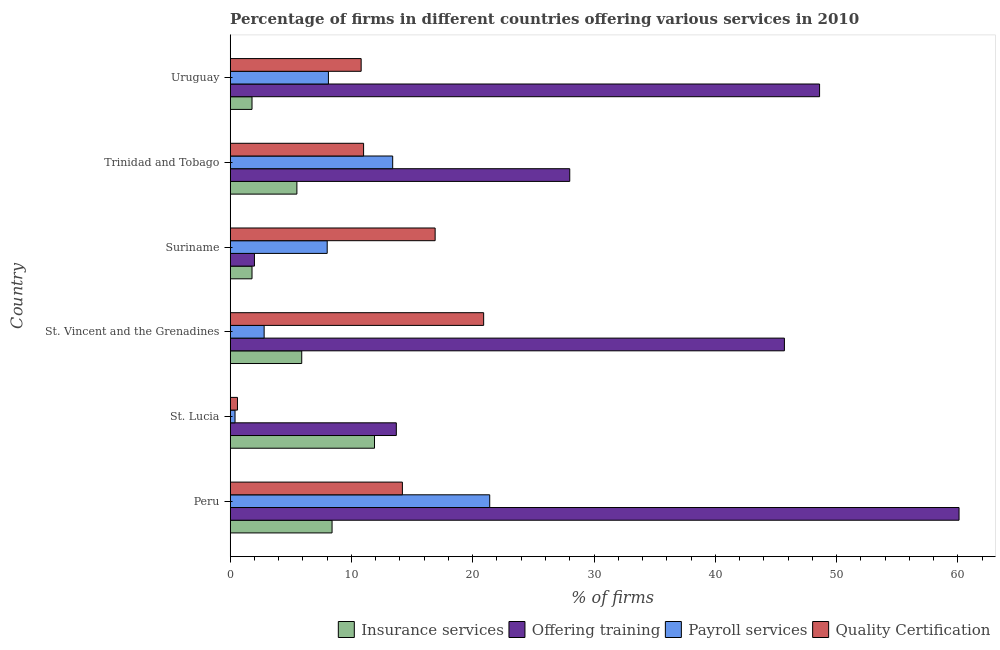How many different coloured bars are there?
Offer a very short reply. 4. Are the number of bars on each tick of the Y-axis equal?
Give a very brief answer. Yes. How many bars are there on the 3rd tick from the top?
Your response must be concise. 4. How many bars are there on the 1st tick from the bottom?
Ensure brevity in your answer.  4. What is the label of the 6th group of bars from the top?
Provide a succinct answer. Peru. Across all countries, what is the maximum percentage of firms offering payroll services?
Ensure brevity in your answer.  21.4. Across all countries, what is the minimum percentage of firms offering payroll services?
Your answer should be very brief. 0.4. In which country was the percentage of firms offering insurance services maximum?
Your answer should be compact. St. Lucia. In which country was the percentage of firms offering payroll services minimum?
Offer a very short reply. St. Lucia. What is the total percentage of firms offering quality certification in the graph?
Your answer should be compact. 74.4. What is the difference between the percentage of firms offering training in St. Lucia and that in Trinidad and Tobago?
Provide a short and direct response. -14.3. What is the average percentage of firms offering payroll services per country?
Your answer should be very brief. 9.02. What is the ratio of the percentage of firms offering training in St. Lucia to that in Uruguay?
Make the answer very short. 0.28. Is the percentage of firms offering insurance services in St. Lucia less than that in Suriname?
Your answer should be compact. No. Is the difference between the percentage of firms offering payroll services in Trinidad and Tobago and Uruguay greater than the difference between the percentage of firms offering insurance services in Trinidad and Tobago and Uruguay?
Provide a succinct answer. Yes. What is the difference between the highest and the lowest percentage of firms offering quality certification?
Ensure brevity in your answer.  20.3. In how many countries, is the percentage of firms offering payroll services greater than the average percentage of firms offering payroll services taken over all countries?
Offer a very short reply. 2. What does the 3rd bar from the top in St. Lucia represents?
Ensure brevity in your answer.  Offering training. What does the 1st bar from the bottom in St. Vincent and the Grenadines represents?
Give a very brief answer. Insurance services. Are the values on the major ticks of X-axis written in scientific E-notation?
Give a very brief answer. No. Does the graph contain any zero values?
Provide a short and direct response. No. Does the graph contain grids?
Offer a terse response. No. How are the legend labels stacked?
Give a very brief answer. Horizontal. What is the title of the graph?
Provide a short and direct response. Percentage of firms in different countries offering various services in 2010. Does "Belgium" appear as one of the legend labels in the graph?
Your answer should be compact. No. What is the label or title of the X-axis?
Your answer should be very brief. % of firms. What is the % of firms of Offering training in Peru?
Provide a short and direct response. 60.1. What is the % of firms in Payroll services in Peru?
Your answer should be compact. 21.4. What is the % of firms of Quality Certification in Peru?
Make the answer very short. 14.2. What is the % of firms of Insurance services in St. Lucia?
Offer a terse response. 11.9. What is the % of firms of Offering training in St. Lucia?
Your answer should be compact. 13.7. What is the % of firms in Quality Certification in St. Lucia?
Ensure brevity in your answer.  0.6. What is the % of firms of Insurance services in St. Vincent and the Grenadines?
Your response must be concise. 5.9. What is the % of firms in Offering training in St. Vincent and the Grenadines?
Make the answer very short. 45.7. What is the % of firms of Payroll services in St. Vincent and the Grenadines?
Provide a succinct answer. 2.8. What is the % of firms in Quality Certification in St. Vincent and the Grenadines?
Provide a short and direct response. 20.9. What is the % of firms in Insurance services in Suriname?
Ensure brevity in your answer.  1.8. What is the % of firms in Offering training in Trinidad and Tobago?
Ensure brevity in your answer.  28. What is the % of firms of Offering training in Uruguay?
Give a very brief answer. 48.6. What is the % of firms in Payroll services in Uruguay?
Offer a very short reply. 8.1. What is the % of firms of Quality Certification in Uruguay?
Make the answer very short. 10.8. Across all countries, what is the maximum % of firms of Offering training?
Provide a short and direct response. 60.1. Across all countries, what is the maximum % of firms of Payroll services?
Make the answer very short. 21.4. Across all countries, what is the maximum % of firms of Quality Certification?
Ensure brevity in your answer.  20.9. Across all countries, what is the minimum % of firms in Insurance services?
Your response must be concise. 1.8. What is the total % of firms in Insurance services in the graph?
Your answer should be very brief. 35.3. What is the total % of firms of Offering training in the graph?
Keep it short and to the point. 198.1. What is the total % of firms in Payroll services in the graph?
Offer a terse response. 54.1. What is the total % of firms in Quality Certification in the graph?
Provide a succinct answer. 74.4. What is the difference between the % of firms in Insurance services in Peru and that in St. Lucia?
Ensure brevity in your answer.  -3.5. What is the difference between the % of firms of Offering training in Peru and that in St. Lucia?
Your answer should be compact. 46.4. What is the difference between the % of firms of Quality Certification in Peru and that in St. Lucia?
Your answer should be very brief. 13.6. What is the difference between the % of firms in Offering training in Peru and that in St. Vincent and the Grenadines?
Give a very brief answer. 14.4. What is the difference between the % of firms of Quality Certification in Peru and that in St. Vincent and the Grenadines?
Your answer should be compact. -6.7. What is the difference between the % of firms of Insurance services in Peru and that in Suriname?
Keep it short and to the point. 6.6. What is the difference between the % of firms of Offering training in Peru and that in Suriname?
Provide a succinct answer. 58.1. What is the difference between the % of firms in Payroll services in Peru and that in Suriname?
Provide a succinct answer. 13.4. What is the difference between the % of firms in Quality Certification in Peru and that in Suriname?
Keep it short and to the point. -2.7. What is the difference between the % of firms in Insurance services in Peru and that in Trinidad and Tobago?
Your answer should be very brief. 2.9. What is the difference between the % of firms of Offering training in Peru and that in Trinidad and Tobago?
Ensure brevity in your answer.  32.1. What is the difference between the % of firms in Payroll services in Peru and that in Trinidad and Tobago?
Offer a terse response. 8. What is the difference between the % of firms in Quality Certification in Peru and that in Trinidad and Tobago?
Ensure brevity in your answer.  3.2. What is the difference between the % of firms in Insurance services in Peru and that in Uruguay?
Offer a terse response. 6.6. What is the difference between the % of firms of Offering training in Peru and that in Uruguay?
Offer a very short reply. 11.5. What is the difference between the % of firms of Quality Certification in Peru and that in Uruguay?
Offer a terse response. 3.4. What is the difference between the % of firms in Insurance services in St. Lucia and that in St. Vincent and the Grenadines?
Give a very brief answer. 6. What is the difference between the % of firms in Offering training in St. Lucia and that in St. Vincent and the Grenadines?
Your answer should be very brief. -32. What is the difference between the % of firms in Payroll services in St. Lucia and that in St. Vincent and the Grenadines?
Keep it short and to the point. -2.4. What is the difference between the % of firms in Quality Certification in St. Lucia and that in St. Vincent and the Grenadines?
Provide a succinct answer. -20.3. What is the difference between the % of firms of Offering training in St. Lucia and that in Suriname?
Provide a succinct answer. 11.7. What is the difference between the % of firms in Payroll services in St. Lucia and that in Suriname?
Offer a very short reply. -7.6. What is the difference between the % of firms of Quality Certification in St. Lucia and that in Suriname?
Make the answer very short. -16.3. What is the difference between the % of firms of Offering training in St. Lucia and that in Trinidad and Tobago?
Provide a short and direct response. -14.3. What is the difference between the % of firms of Quality Certification in St. Lucia and that in Trinidad and Tobago?
Make the answer very short. -10.4. What is the difference between the % of firms in Insurance services in St. Lucia and that in Uruguay?
Your answer should be very brief. 10.1. What is the difference between the % of firms in Offering training in St. Lucia and that in Uruguay?
Offer a terse response. -34.9. What is the difference between the % of firms of Payroll services in St. Lucia and that in Uruguay?
Your answer should be very brief. -7.7. What is the difference between the % of firms in Quality Certification in St. Lucia and that in Uruguay?
Your response must be concise. -10.2. What is the difference between the % of firms of Offering training in St. Vincent and the Grenadines and that in Suriname?
Your answer should be compact. 43.7. What is the difference between the % of firms of Payroll services in St. Vincent and the Grenadines and that in Suriname?
Your answer should be very brief. -5.2. What is the difference between the % of firms in Insurance services in St. Vincent and the Grenadines and that in Trinidad and Tobago?
Keep it short and to the point. 0.4. What is the difference between the % of firms in Offering training in St. Vincent and the Grenadines and that in Trinidad and Tobago?
Offer a very short reply. 17.7. What is the difference between the % of firms of Payroll services in St. Vincent and the Grenadines and that in Trinidad and Tobago?
Offer a terse response. -10.6. What is the difference between the % of firms of Insurance services in St. Vincent and the Grenadines and that in Uruguay?
Your answer should be compact. 4.1. What is the difference between the % of firms of Insurance services in Suriname and that in Trinidad and Tobago?
Offer a terse response. -3.7. What is the difference between the % of firms of Offering training in Suriname and that in Trinidad and Tobago?
Your answer should be compact. -26. What is the difference between the % of firms in Quality Certification in Suriname and that in Trinidad and Tobago?
Your answer should be compact. 5.9. What is the difference between the % of firms in Insurance services in Suriname and that in Uruguay?
Your answer should be very brief. 0. What is the difference between the % of firms in Offering training in Suriname and that in Uruguay?
Your answer should be compact. -46.6. What is the difference between the % of firms of Payroll services in Suriname and that in Uruguay?
Make the answer very short. -0.1. What is the difference between the % of firms of Quality Certification in Suriname and that in Uruguay?
Keep it short and to the point. 6.1. What is the difference between the % of firms in Insurance services in Trinidad and Tobago and that in Uruguay?
Provide a short and direct response. 3.7. What is the difference between the % of firms of Offering training in Trinidad and Tobago and that in Uruguay?
Your answer should be compact. -20.6. What is the difference between the % of firms in Quality Certification in Trinidad and Tobago and that in Uruguay?
Provide a succinct answer. 0.2. What is the difference between the % of firms in Insurance services in Peru and the % of firms in Offering training in St. Lucia?
Your answer should be compact. -5.3. What is the difference between the % of firms of Insurance services in Peru and the % of firms of Payroll services in St. Lucia?
Your response must be concise. 8. What is the difference between the % of firms in Insurance services in Peru and the % of firms in Quality Certification in St. Lucia?
Your answer should be compact. 7.8. What is the difference between the % of firms in Offering training in Peru and the % of firms in Payroll services in St. Lucia?
Give a very brief answer. 59.7. What is the difference between the % of firms in Offering training in Peru and the % of firms in Quality Certification in St. Lucia?
Your answer should be very brief. 59.5. What is the difference between the % of firms of Payroll services in Peru and the % of firms of Quality Certification in St. Lucia?
Your answer should be compact. 20.8. What is the difference between the % of firms of Insurance services in Peru and the % of firms of Offering training in St. Vincent and the Grenadines?
Provide a succinct answer. -37.3. What is the difference between the % of firms in Insurance services in Peru and the % of firms in Payroll services in St. Vincent and the Grenadines?
Provide a succinct answer. 5.6. What is the difference between the % of firms in Insurance services in Peru and the % of firms in Quality Certification in St. Vincent and the Grenadines?
Offer a terse response. -12.5. What is the difference between the % of firms in Offering training in Peru and the % of firms in Payroll services in St. Vincent and the Grenadines?
Provide a short and direct response. 57.3. What is the difference between the % of firms of Offering training in Peru and the % of firms of Quality Certification in St. Vincent and the Grenadines?
Ensure brevity in your answer.  39.2. What is the difference between the % of firms in Insurance services in Peru and the % of firms in Offering training in Suriname?
Your response must be concise. 6.4. What is the difference between the % of firms of Insurance services in Peru and the % of firms of Payroll services in Suriname?
Provide a succinct answer. 0.4. What is the difference between the % of firms of Offering training in Peru and the % of firms of Payroll services in Suriname?
Your answer should be compact. 52.1. What is the difference between the % of firms of Offering training in Peru and the % of firms of Quality Certification in Suriname?
Provide a short and direct response. 43.2. What is the difference between the % of firms of Insurance services in Peru and the % of firms of Offering training in Trinidad and Tobago?
Give a very brief answer. -19.6. What is the difference between the % of firms of Insurance services in Peru and the % of firms of Quality Certification in Trinidad and Tobago?
Provide a succinct answer. -2.6. What is the difference between the % of firms in Offering training in Peru and the % of firms in Payroll services in Trinidad and Tobago?
Offer a very short reply. 46.7. What is the difference between the % of firms in Offering training in Peru and the % of firms in Quality Certification in Trinidad and Tobago?
Give a very brief answer. 49.1. What is the difference between the % of firms of Insurance services in Peru and the % of firms of Offering training in Uruguay?
Offer a very short reply. -40.2. What is the difference between the % of firms in Insurance services in Peru and the % of firms in Payroll services in Uruguay?
Give a very brief answer. 0.3. What is the difference between the % of firms of Offering training in Peru and the % of firms of Payroll services in Uruguay?
Make the answer very short. 52. What is the difference between the % of firms of Offering training in Peru and the % of firms of Quality Certification in Uruguay?
Offer a terse response. 49.3. What is the difference between the % of firms in Insurance services in St. Lucia and the % of firms in Offering training in St. Vincent and the Grenadines?
Your response must be concise. -33.8. What is the difference between the % of firms in Insurance services in St. Lucia and the % of firms in Quality Certification in St. Vincent and the Grenadines?
Keep it short and to the point. -9. What is the difference between the % of firms of Offering training in St. Lucia and the % of firms of Quality Certification in St. Vincent and the Grenadines?
Offer a terse response. -7.2. What is the difference between the % of firms in Payroll services in St. Lucia and the % of firms in Quality Certification in St. Vincent and the Grenadines?
Keep it short and to the point. -20.5. What is the difference between the % of firms of Insurance services in St. Lucia and the % of firms of Offering training in Suriname?
Provide a short and direct response. 9.9. What is the difference between the % of firms in Offering training in St. Lucia and the % of firms in Payroll services in Suriname?
Offer a terse response. 5.7. What is the difference between the % of firms of Offering training in St. Lucia and the % of firms of Quality Certification in Suriname?
Make the answer very short. -3.2. What is the difference between the % of firms of Payroll services in St. Lucia and the % of firms of Quality Certification in Suriname?
Keep it short and to the point. -16.5. What is the difference between the % of firms of Insurance services in St. Lucia and the % of firms of Offering training in Trinidad and Tobago?
Your answer should be compact. -16.1. What is the difference between the % of firms of Offering training in St. Lucia and the % of firms of Payroll services in Trinidad and Tobago?
Ensure brevity in your answer.  0.3. What is the difference between the % of firms of Payroll services in St. Lucia and the % of firms of Quality Certification in Trinidad and Tobago?
Keep it short and to the point. -10.6. What is the difference between the % of firms in Insurance services in St. Lucia and the % of firms in Offering training in Uruguay?
Ensure brevity in your answer.  -36.7. What is the difference between the % of firms of Insurance services in St. Lucia and the % of firms of Quality Certification in Uruguay?
Provide a short and direct response. 1.1. What is the difference between the % of firms of Payroll services in St. Lucia and the % of firms of Quality Certification in Uruguay?
Ensure brevity in your answer.  -10.4. What is the difference between the % of firms in Insurance services in St. Vincent and the Grenadines and the % of firms in Offering training in Suriname?
Give a very brief answer. 3.9. What is the difference between the % of firms of Insurance services in St. Vincent and the Grenadines and the % of firms of Quality Certification in Suriname?
Your response must be concise. -11. What is the difference between the % of firms in Offering training in St. Vincent and the Grenadines and the % of firms in Payroll services in Suriname?
Your answer should be compact. 37.7. What is the difference between the % of firms of Offering training in St. Vincent and the Grenadines and the % of firms of Quality Certification in Suriname?
Offer a very short reply. 28.8. What is the difference between the % of firms of Payroll services in St. Vincent and the Grenadines and the % of firms of Quality Certification in Suriname?
Offer a terse response. -14.1. What is the difference between the % of firms of Insurance services in St. Vincent and the Grenadines and the % of firms of Offering training in Trinidad and Tobago?
Give a very brief answer. -22.1. What is the difference between the % of firms of Insurance services in St. Vincent and the Grenadines and the % of firms of Payroll services in Trinidad and Tobago?
Your answer should be compact. -7.5. What is the difference between the % of firms in Offering training in St. Vincent and the Grenadines and the % of firms in Payroll services in Trinidad and Tobago?
Your response must be concise. 32.3. What is the difference between the % of firms in Offering training in St. Vincent and the Grenadines and the % of firms in Quality Certification in Trinidad and Tobago?
Provide a succinct answer. 34.7. What is the difference between the % of firms in Insurance services in St. Vincent and the Grenadines and the % of firms in Offering training in Uruguay?
Offer a very short reply. -42.7. What is the difference between the % of firms of Insurance services in St. Vincent and the Grenadines and the % of firms of Payroll services in Uruguay?
Give a very brief answer. -2.2. What is the difference between the % of firms of Insurance services in St. Vincent and the Grenadines and the % of firms of Quality Certification in Uruguay?
Your response must be concise. -4.9. What is the difference between the % of firms of Offering training in St. Vincent and the Grenadines and the % of firms of Payroll services in Uruguay?
Your answer should be very brief. 37.6. What is the difference between the % of firms of Offering training in St. Vincent and the Grenadines and the % of firms of Quality Certification in Uruguay?
Offer a very short reply. 34.9. What is the difference between the % of firms of Payroll services in St. Vincent and the Grenadines and the % of firms of Quality Certification in Uruguay?
Your answer should be very brief. -8. What is the difference between the % of firms of Insurance services in Suriname and the % of firms of Offering training in Trinidad and Tobago?
Make the answer very short. -26.2. What is the difference between the % of firms of Insurance services in Suriname and the % of firms of Payroll services in Trinidad and Tobago?
Provide a succinct answer. -11.6. What is the difference between the % of firms of Insurance services in Suriname and the % of firms of Quality Certification in Trinidad and Tobago?
Give a very brief answer. -9.2. What is the difference between the % of firms in Offering training in Suriname and the % of firms in Payroll services in Trinidad and Tobago?
Make the answer very short. -11.4. What is the difference between the % of firms in Insurance services in Suriname and the % of firms in Offering training in Uruguay?
Your response must be concise. -46.8. What is the difference between the % of firms in Insurance services in Suriname and the % of firms in Payroll services in Uruguay?
Offer a terse response. -6.3. What is the difference between the % of firms of Insurance services in Suriname and the % of firms of Quality Certification in Uruguay?
Ensure brevity in your answer.  -9. What is the difference between the % of firms in Offering training in Suriname and the % of firms in Quality Certification in Uruguay?
Your answer should be very brief. -8.8. What is the difference between the % of firms of Insurance services in Trinidad and Tobago and the % of firms of Offering training in Uruguay?
Make the answer very short. -43.1. What is the difference between the % of firms in Insurance services in Trinidad and Tobago and the % of firms in Payroll services in Uruguay?
Offer a terse response. -2.6. What is the difference between the % of firms of Offering training in Trinidad and Tobago and the % of firms of Quality Certification in Uruguay?
Ensure brevity in your answer.  17.2. What is the difference between the % of firms of Payroll services in Trinidad and Tobago and the % of firms of Quality Certification in Uruguay?
Provide a short and direct response. 2.6. What is the average % of firms of Insurance services per country?
Give a very brief answer. 5.88. What is the average % of firms of Offering training per country?
Give a very brief answer. 33.02. What is the average % of firms in Payroll services per country?
Give a very brief answer. 9.02. What is the difference between the % of firms in Insurance services and % of firms in Offering training in Peru?
Offer a terse response. -51.7. What is the difference between the % of firms in Offering training and % of firms in Payroll services in Peru?
Make the answer very short. 38.7. What is the difference between the % of firms in Offering training and % of firms in Quality Certification in Peru?
Offer a terse response. 45.9. What is the difference between the % of firms of Offering training and % of firms of Quality Certification in St. Lucia?
Make the answer very short. 13.1. What is the difference between the % of firms in Insurance services and % of firms in Offering training in St. Vincent and the Grenadines?
Make the answer very short. -39.8. What is the difference between the % of firms in Insurance services and % of firms in Payroll services in St. Vincent and the Grenadines?
Your response must be concise. 3.1. What is the difference between the % of firms in Insurance services and % of firms in Quality Certification in St. Vincent and the Grenadines?
Ensure brevity in your answer.  -15. What is the difference between the % of firms in Offering training and % of firms in Payroll services in St. Vincent and the Grenadines?
Offer a terse response. 42.9. What is the difference between the % of firms in Offering training and % of firms in Quality Certification in St. Vincent and the Grenadines?
Offer a terse response. 24.8. What is the difference between the % of firms of Payroll services and % of firms of Quality Certification in St. Vincent and the Grenadines?
Give a very brief answer. -18.1. What is the difference between the % of firms in Insurance services and % of firms in Offering training in Suriname?
Offer a very short reply. -0.2. What is the difference between the % of firms of Insurance services and % of firms of Quality Certification in Suriname?
Make the answer very short. -15.1. What is the difference between the % of firms of Offering training and % of firms of Payroll services in Suriname?
Keep it short and to the point. -6. What is the difference between the % of firms in Offering training and % of firms in Quality Certification in Suriname?
Keep it short and to the point. -14.9. What is the difference between the % of firms in Insurance services and % of firms in Offering training in Trinidad and Tobago?
Your answer should be very brief. -22.5. What is the difference between the % of firms of Insurance services and % of firms of Offering training in Uruguay?
Your response must be concise. -46.8. What is the difference between the % of firms in Insurance services and % of firms in Payroll services in Uruguay?
Make the answer very short. -6.3. What is the difference between the % of firms in Insurance services and % of firms in Quality Certification in Uruguay?
Ensure brevity in your answer.  -9. What is the difference between the % of firms in Offering training and % of firms in Payroll services in Uruguay?
Your response must be concise. 40.5. What is the difference between the % of firms of Offering training and % of firms of Quality Certification in Uruguay?
Your answer should be very brief. 37.8. What is the ratio of the % of firms in Insurance services in Peru to that in St. Lucia?
Ensure brevity in your answer.  0.71. What is the ratio of the % of firms in Offering training in Peru to that in St. Lucia?
Your answer should be compact. 4.39. What is the ratio of the % of firms in Payroll services in Peru to that in St. Lucia?
Give a very brief answer. 53.5. What is the ratio of the % of firms of Quality Certification in Peru to that in St. Lucia?
Your response must be concise. 23.67. What is the ratio of the % of firms in Insurance services in Peru to that in St. Vincent and the Grenadines?
Offer a very short reply. 1.42. What is the ratio of the % of firms of Offering training in Peru to that in St. Vincent and the Grenadines?
Offer a terse response. 1.32. What is the ratio of the % of firms in Payroll services in Peru to that in St. Vincent and the Grenadines?
Keep it short and to the point. 7.64. What is the ratio of the % of firms of Quality Certification in Peru to that in St. Vincent and the Grenadines?
Ensure brevity in your answer.  0.68. What is the ratio of the % of firms in Insurance services in Peru to that in Suriname?
Provide a succinct answer. 4.67. What is the ratio of the % of firms of Offering training in Peru to that in Suriname?
Provide a short and direct response. 30.05. What is the ratio of the % of firms in Payroll services in Peru to that in Suriname?
Ensure brevity in your answer.  2.67. What is the ratio of the % of firms of Quality Certification in Peru to that in Suriname?
Your answer should be very brief. 0.84. What is the ratio of the % of firms of Insurance services in Peru to that in Trinidad and Tobago?
Your response must be concise. 1.53. What is the ratio of the % of firms in Offering training in Peru to that in Trinidad and Tobago?
Your answer should be very brief. 2.15. What is the ratio of the % of firms in Payroll services in Peru to that in Trinidad and Tobago?
Your answer should be very brief. 1.6. What is the ratio of the % of firms of Quality Certification in Peru to that in Trinidad and Tobago?
Your answer should be very brief. 1.29. What is the ratio of the % of firms in Insurance services in Peru to that in Uruguay?
Offer a terse response. 4.67. What is the ratio of the % of firms of Offering training in Peru to that in Uruguay?
Provide a succinct answer. 1.24. What is the ratio of the % of firms of Payroll services in Peru to that in Uruguay?
Ensure brevity in your answer.  2.64. What is the ratio of the % of firms of Quality Certification in Peru to that in Uruguay?
Provide a succinct answer. 1.31. What is the ratio of the % of firms of Insurance services in St. Lucia to that in St. Vincent and the Grenadines?
Provide a succinct answer. 2.02. What is the ratio of the % of firms in Offering training in St. Lucia to that in St. Vincent and the Grenadines?
Offer a very short reply. 0.3. What is the ratio of the % of firms of Payroll services in St. Lucia to that in St. Vincent and the Grenadines?
Your answer should be compact. 0.14. What is the ratio of the % of firms in Quality Certification in St. Lucia to that in St. Vincent and the Grenadines?
Offer a very short reply. 0.03. What is the ratio of the % of firms of Insurance services in St. Lucia to that in Suriname?
Ensure brevity in your answer.  6.61. What is the ratio of the % of firms of Offering training in St. Lucia to that in Suriname?
Make the answer very short. 6.85. What is the ratio of the % of firms of Payroll services in St. Lucia to that in Suriname?
Provide a succinct answer. 0.05. What is the ratio of the % of firms of Quality Certification in St. Lucia to that in Suriname?
Give a very brief answer. 0.04. What is the ratio of the % of firms in Insurance services in St. Lucia to that in Trinidad and Tobago?
Your response must be concise. 2.16. What is the ratio of the % of firms of Offering training in St. Lucia to that in Trinidad and Tobago?
Offer a terse response. 0.49. What is the ratio of the % of firms of Payroll services in St. Lucia to that in Trinidad and Tobago?
Provide a succinct answer. 0.03. What is the ratio of the % of firms in Quality Certification in St. Lucia to that in Trinidad and Tobago?
Offer a very short reply. 0.05. What is the ratio of the % of firms in Insurance services in St. Lucia to that in Uruguay?
Give a very brief answer. 6.61. What is the ratio of the % of firms in Offering training in St. Lucia to that in Uruguay?
Ensure brevity in your answer.  0.28. What is the ratio of the % of firms of Payroll services in St. Lucia to that in Uruguay?
Offer a very short reply. 0.05. What is the ratio of the % of firms of Quality Certification in St. Lucia to that in Uruguay?
Offer a very short reply. 0.06. What is the ratio of the % of firms of Insurance services in St. Vincent and the Grenadines to that in Suriname?
Provide a short and direct response. 3.28. What is the ratio of the % of firms in Offering training in St. Vincent and the Grenadines to that in Suriname?
Offer a very short reply. 22.85. What is the ratio of the % of firms of Quality Certification in St. Vincent and the Grenadines to that in Suriname?
Give a very brief answer. 1.24. What is the ratio of the % of firms in Insurance services in St. Vincent and the Grenadines to that in Trinidad and Tobago?
Your response must be concise. 1.07. What is the ratio of the % of firms of Offering training in St. Vincent and the Grenadines to that in Trinidad and Tobago?
Give a very brief answer. 1.63. What is the ratio of the % of firms of Payroll services in St. Vincent and the Grenadines to that in Trinidad and Tobago?
Your response must be concise. 0.21. What is the ratio of the % of firms of Quality Certification in St. Vincent and the Grenadines to that in Trinidad and Tobago?
Your response must be concise. 1.9. What is the ratio of the % of firms in Insurance services in St. Vincent and the Grenadines to that in Uruguay?
Your answer should be compact. 3.28. What is the ratio of the % of firms of Offering training in St. Vincent and the Grenadines to that in Uruguay?
Make the answer very short. 0.94. What is the ratio of the % of firms of Payroll services in St. Vincent and the Grenadines to that in Uruguay?
Provide a short and direct response. 0.35. What is the ratio of the % of firms of Quality Certification in St. Vincent and the Grenadines to that in Uruguay?
Provide a short and direct response. 1.94. What is the ratio of the % of firms in Insurance services in Suriname to that in Trinidad and Tobago?
Give a very brief answer. 0.33. What is the ratio of the % of firms of Offering training in Suriname to that in Trinidad and Tobago?
Ensure brevity in your answer.  0.07. What is the ratio of the % of firms of Payroll services in Suriname to that in Trinidad and Tobago?
Provide a succinct answer. 0.6. What is the ratio of the % of firms in Quality Certification in Suriname to that in Trinidad and Tobago?
Your response must be concise. 1.54. What is the ratio of the % of firms of Offering training in Suriname to that in Uruguay?
Provide a succinct answer. 0.04. What is the ratio of the % of firms of Payroll services in Suriname to that in Uruguay?
Keep it short and to the point. 0.99. What is the ratio of the % of firms of Quality Certification in Suriname to that in Uruguay?
Your answer should be very brief. 1.56. What is the ratio of the % of firms in Insurance services in Trinidad and Tobago to that in Uruguay?
Your answer should be very brief. 3.06. What is the ratio of the % of firms of Offering training in Trinidad and Tobago to that in Uruguay?
Your answer should be very brief. 0.58. What is the ratio of the % of firms in Payroll services in Trinidad and Tobago to that in Uruguay?
Provide a short and direct response. 1.65. What is the ratio of the % of firms in Quality Certification in Trinidad and Tobago to that in Uruguay?
Give a very brief answer. 1.02. What is the difference between the highest and the second highest % of firms of Payroll services?
Ensure brevity in your answer.  8. What is the difference between the highest and the lowest % of firms in Insurance services?
Offer a terse response. 10.1. What is the difference between the highest and the lowest % of firms in Offering training?
Your response must be concise. 58.1. What is the difference between the highest and the lowest % of firms of Payroll services?
Provide a short and direct response. 21. What is the difference between the highest and the lowest % of firms in Quality Certification?
Give a very brief answer. 20.3. 